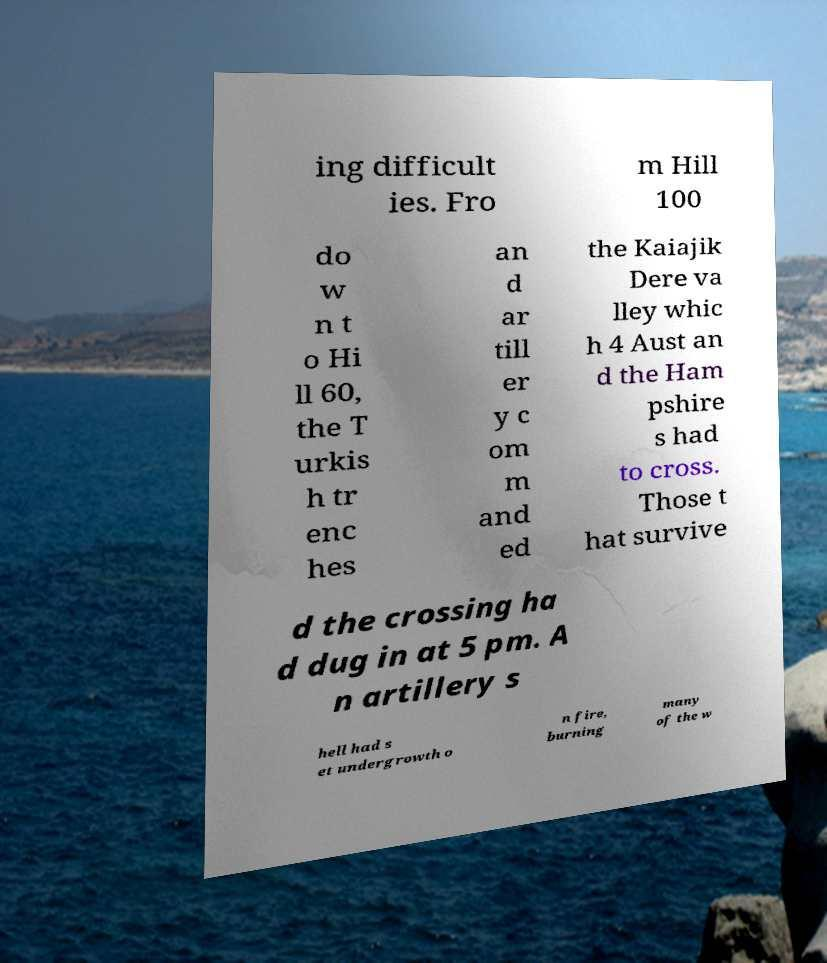What messages or text are displayed in this image? I need them in a readable, typed format. ing difficult ies. Fro m Hill 100 do w n t o Hi ll 60, the T urkis h tr enc hes an d ar till er y c om m and ed the Kaiajik Dere va lley whic h 4 Aust an d the Ham pshire s had to cross. Those t hat survive d the crossing ha d dug in at 5 pm. A n artillery s hell had s et undergrowth o n fire, burning many of the w 